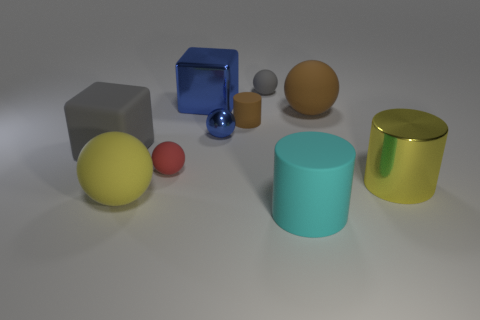Subtract all small gray matte balls. How many balls are left? 4 Subtract all yellow spheres. How many spheres are left? 4 Subtract all purple balls. Subtract all green cylinders. How many balls are left? 5 Subtract all blocks. How many objects are left? 8 Add 6 big gray objects. How many big gray objects exist? 7 Subtract 0 purple balls. How many objects are left? 10 Subtract all large green metallic cylinders. Subtract all small cylinders. How many objects are left? 9 Add 5 big shiny cylinders. How many big shiny cylinders are left? 6 